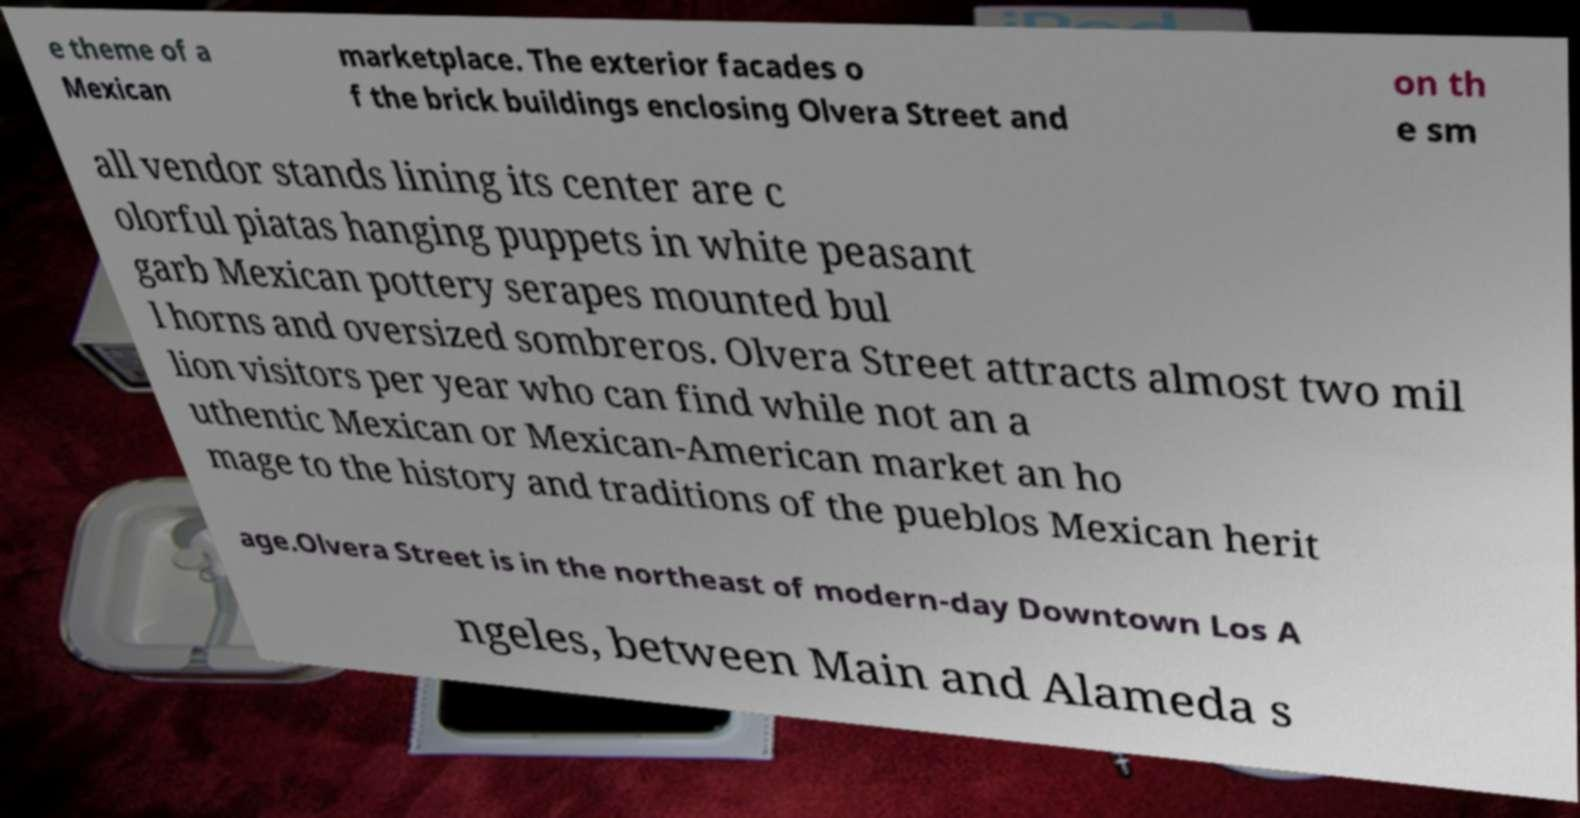What messages or text are displayed in this image? I need them in a readable, typed format. e theme of a Mexican marketplace. The exterior facades o f the brick buildings enclosing Olvera Street and on th e sm all vendor stands lining its center are c olorful piatas hanging puppets in white peasant garb Mexican pottery serapes mounted bul l horns and oversized sombreros. Olvera Street attracts almost two mil lion visitors per year who can find while not an a uthentic Mexican or Mexican-American market an ho mage to the history and traditions of the pueblos Mexican herit age.Olvera Street is in the northeast of modern-day Downtown Los A ngeles, between Main and Alameda s 